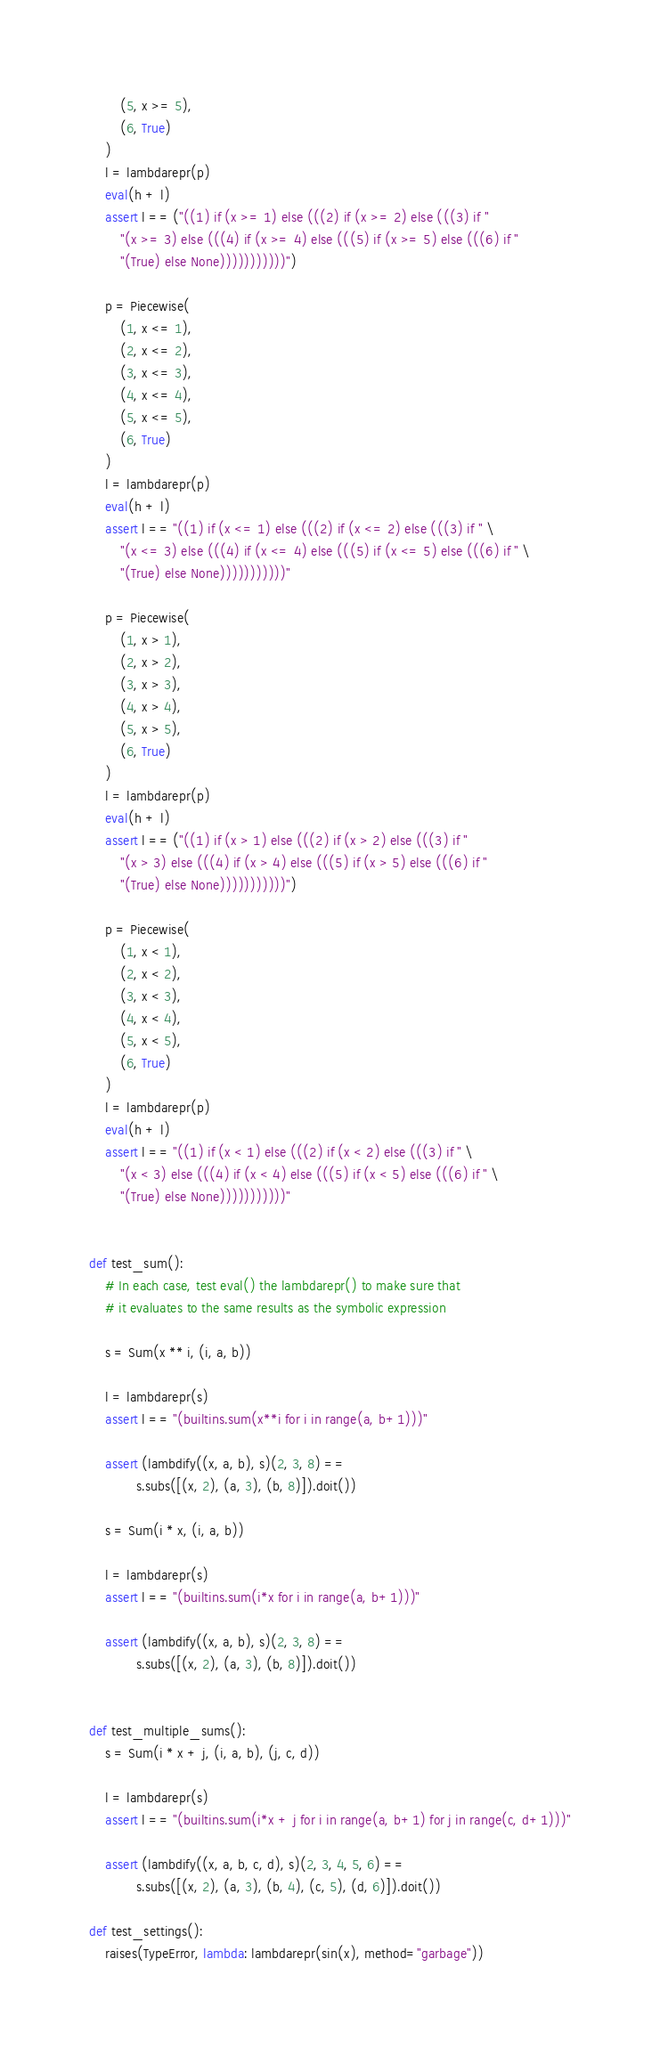<code> <loc_0><loc_0><loc_500><loc_500><_Python_>        (5, x >= 5),
        (6, True)
    )
    l = lambdarepr(p)
    eval(h + l)
    assert l == ("((1) if (x >= 1) else (((2) if (x >= 2) else (((3) if "
        "(x >= 3) else (((4) if (x >= 4) else (((5) if (x >= 5) else (((6) if "
        "(True) else None)))))))))))")

    p = Piecewise(
        (1, x <= 1),
        (2, x <= 2),
        (3, x <= 3),
        (4, x <= 4),
        (5, x <= 5),
        (6, True)
    )
    l = lambdarepr(p)
    eval(h + l)
    assert l == "((1) if (x <= 1) else (((2) if (x <= 2) else (((3) if " \
        "(x <= 3) else (((4) if (x <= 4) else (((5) if (x <= 5) else (((6) if " \
        "(True) else None)))))))))))"

    p = Piecewise(
        (1, x > 1),
        (2, x > 2),
        (3, x > 3),
        (4, x > 4),
        (5, x > 5),
        (6, True)
    )
    l = lambdarepr(p)
    eval(h + l)
    assert l == ("((1) if (x > 1) else (((2) if (x > 2) else (((3) if "
        "(x > 3) else (((4) if (x > 4) else (((5) if (x > 5) else (((6) if "
        "(True) else None)))))))))))")

    p = Piecewise(
        (1, x < 1),
        (2, x < 2),
        (3, x < 3),
        (4, x < 4),
        (5, x < 5),
        (6, True)
    )
    l = lambdarepr(p)
    eval(h + l)
    assert l == "((1) if (x < 1) else (((2) if (x < 2) else (((3) if " \
        "(x < 3) else (((4) if (x < 4) else (((5) if (x < 5) else (((6) if " \
        "(True) else None)))))))))))"


def test_sum():
    # In each case, test eval() the lambdarepr() to make sure that
    # it evaluates to the same results as the symbolic expression

    s = Sum(x ** i, (i, a, b))

    l = lambdarepr(s)
    assert l == "(builtins.sum(x**i for i in range(a, b+1)))"

    assert (lambdify((x, a, b), s)(2, 3, 8) ==
            s.subs([(x, 2), (a, 3), (b, 8)]).doit())

    s = Sum(i * x, (i, a, b))

    l = lambdarepr(s)
    assert l == "(builtins.sum(i*x for i in range(a, b+1)))"

    assert (lambdify((x, a, b), s)(2, 3, 8) ==
            s.subs([(x, 2), (a, 3), (b, 8)]).doit())


def test_multiple_sums():
    s = Sum(i * x + j, (i, a, b), (j, c, d))

    l = lambdarepr(s)
    assert l == "(builtins.sum(i*x + j for i in range(a, b+1) for j in range(c, d+1)))"

    assert (lambdify((x, a, b, c, d), s)(2, 3, 4, 5, 6) ==
            s.subs([(x, 2), (a, 3), (b, 4), (c, 5), (d, 6)]).doit())

def test_settings():
    raises(TypeError, lambda: lambdarepr(sin(x), method="garbage"))
</code> 